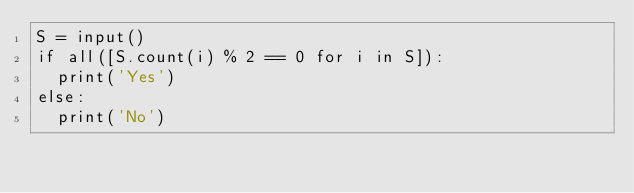Convert code to text. <code><loc_0><loc_0><loc_500><loc_500><_Python_>S = input()
if all([S.count(i) % 2 == 0 for i in S]):
  print('Yes')
else:
  print('No')</code> 